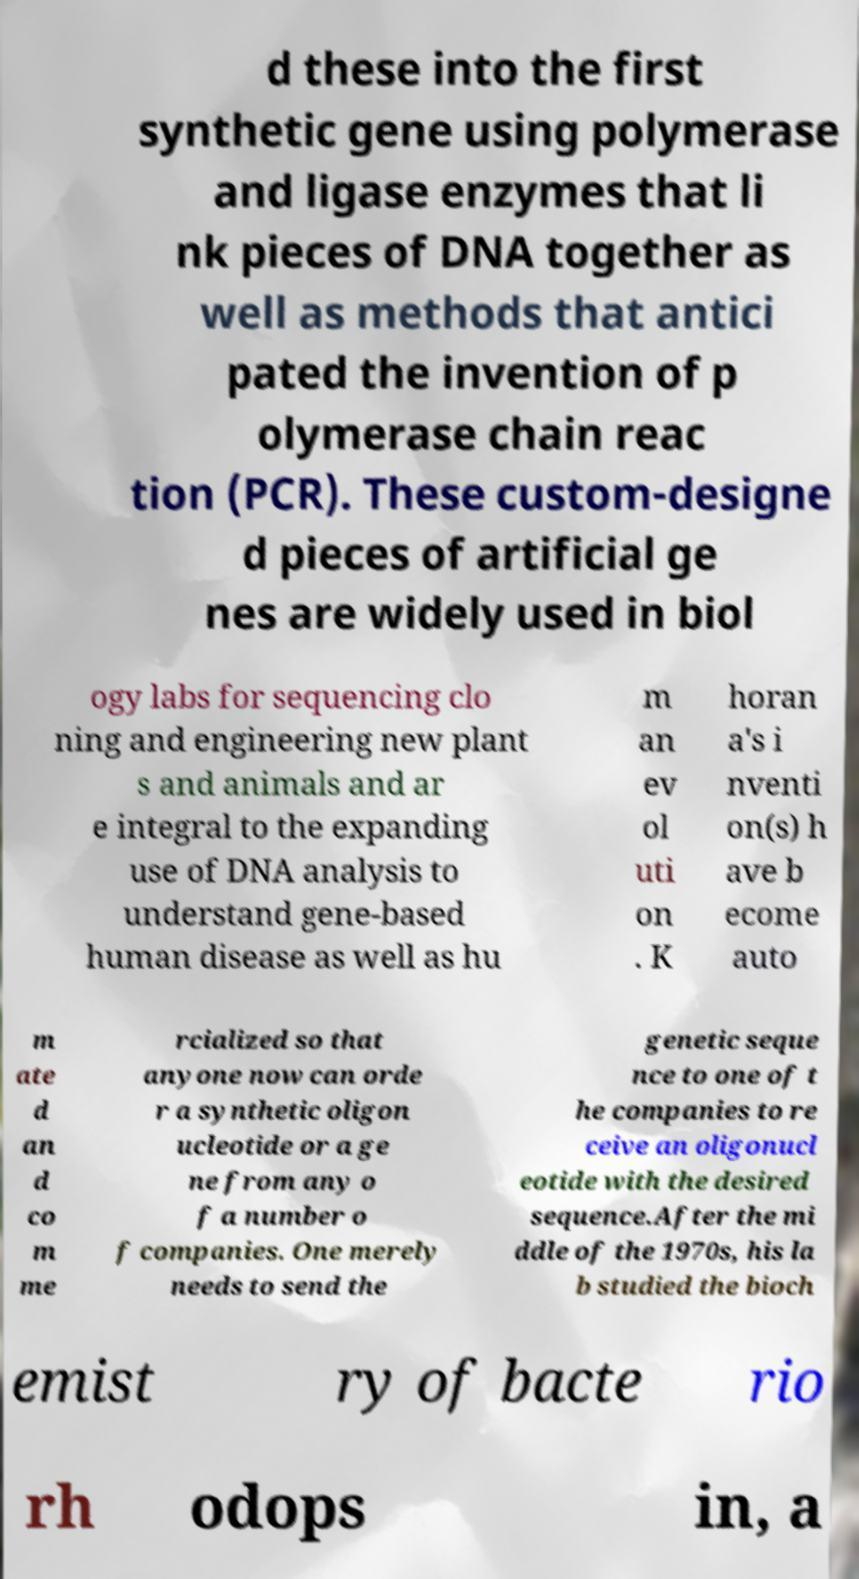Could you extract and type out the text from this image? d these into the first synthetic gene using polymerase and ligase enzymes that li nk pieces of DNA together as well as methods that antici pated the invention of p olymerase chain reac tion (PCR). These custom-designe d pieces of artificial ge nes are widely used in biol ogy labs for sequencing clo ning and engineering new plant s and animals and ar e integral to the expanding use of DNA analysis to understand gene-based human disease as well as hu m an ev ol uti on . K horan a's i nventi on(s) h ave b ecome auto m ate d an d co m me rcialized so that anyone now can orde r a synthetic oligon ucleotide or a ge ne from any o f a number o f companies. One merely needs to send the genetic seque nce to one of t he companies to re ceive an oligonucl eotide with the desired sequence.After the mi ddle of the 1970s, his la b studied the bioch emist ry of bacte rio rh odops in, a 